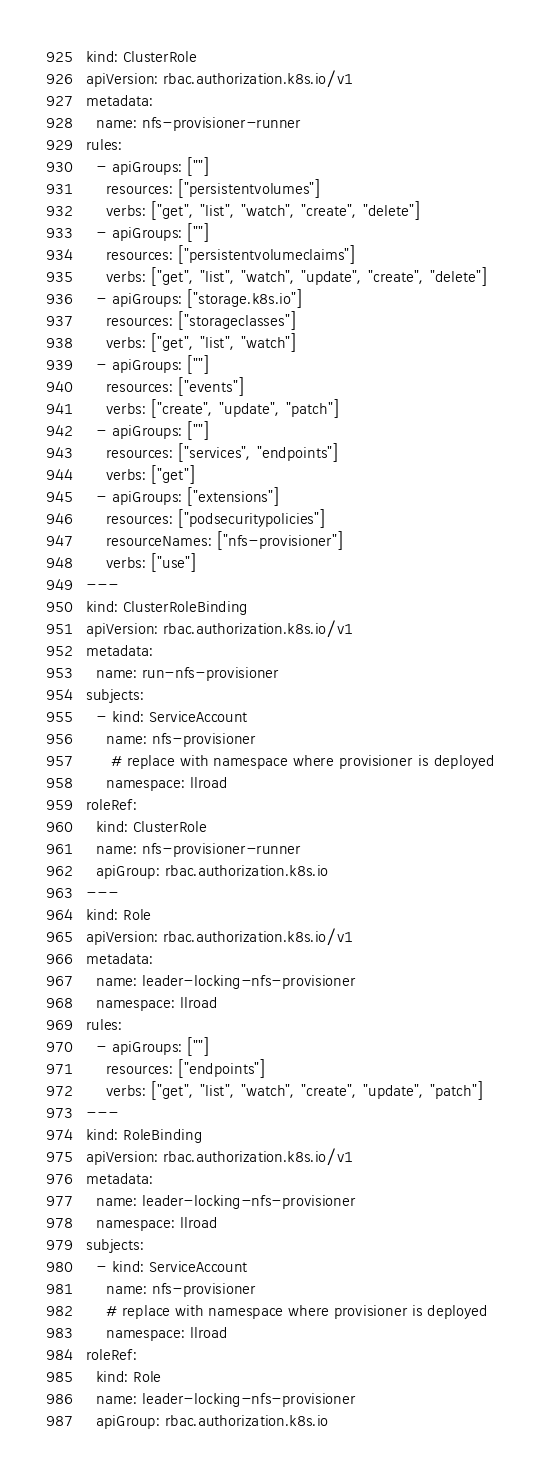<code> <loc_0><loc_0><loc_500><loc_500><_YAML_>kind: ClusterRole
apiVersion: rbac.authorization.k8s.io/v1
metadata:
  name: nfs-provisioner-runner
rules:
  - apiGroups: [""]
    resources: ["persistentvolumes"]
    verbs: ["get", "list", "watch", "create", "delete"]
  - apiGroups: [""]
    resources: ["persistentvolumeclaims"]
    verbs: ["get", "list", "watch", "update", "create", "delete"]
  - apiGroups: ["storage.k8s.io"]
    resources: ["storageclasses"]
    verbs: ["get", "list", "watch"]
  - apiGroups: [""]
    resources: ["events"]
    verbs: ["create", "update", "patch"]
  - apiGroups: [""]
    resources: ["services", "endpoints"]
    verbs: ["get"]
  - apiGroups: ["extensions"]
    resources: ["podsecuritypolicies"]
    resourceNames: ["nfs-provisioner"]
    verbs: ["use"]
---
kind: ClusterRoleBinding
apiVersion: rbac.authorization.k8s.io/v1
metadata:
  name: run-nfs-provisioner
subjects:
  - kind: ServiceAccount
    name: nfs-provisioner
     # replace with namespace where provisioner is deployed
    namespace: llroad
roleRef:
  kind: ClusterRole
  name: nfs-provisioner-runner
  apiGroup: rbac.authorization.k8s.io
---
kind: Role
apiVersion: rbac.authorization.k8s.io/v1
metadata:
  name: leader-locking-nfs-provisioner
  namespace: llroad
rules:
  - apiGroups: [""]
    resources: ["endpoints"]
    verbs: ["get", "list", "watch", "create", "update", "patch"]
---
kind: RoleBinding
apiVersion: rbac.authorization.k8s.io/v1
metadata:
  name: leader-locking-nfs-provisioner
  namespace: llroad
subjects:
  - kind: ServiceAccount
    name: nfs-provisioner
    # replace with namespace where provisioner is deployed
    namespace: llroad
roleRef:
  kind: Role
  name: leader-locking-nfs-provisioner
  apiGroup: rbac.authorization.k8s.io
</code> 